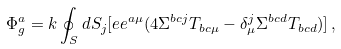<formula> <loc_0><loc_0><loc_500><loc_500>\Phi ^ { a } _ { g } = k \oint _ { S } d S _ { j } [ e e ^ { a \mu } ( 4 \Sigma ^ { b c j } T _ { b c \mu } - \delta ^ { j } _ { \mu } \Sigma ^ { b c d } T _ { b c d } ) ] \, ,</formula> 